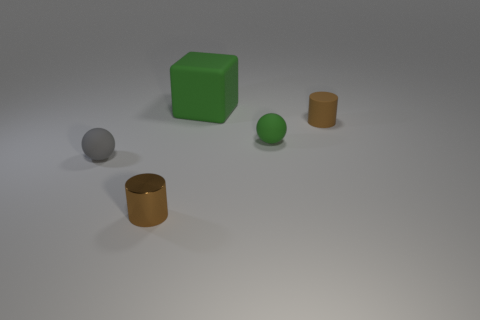What materials do the objects in the image appear to be made of? The objects in the image seem to be digital renderings, but they give an impression of being made from different materials. The cube could represent something with a matte surface similar to plastic, while the spheres and cylinders resemble metallic surfaces due to their reflective qualities. 